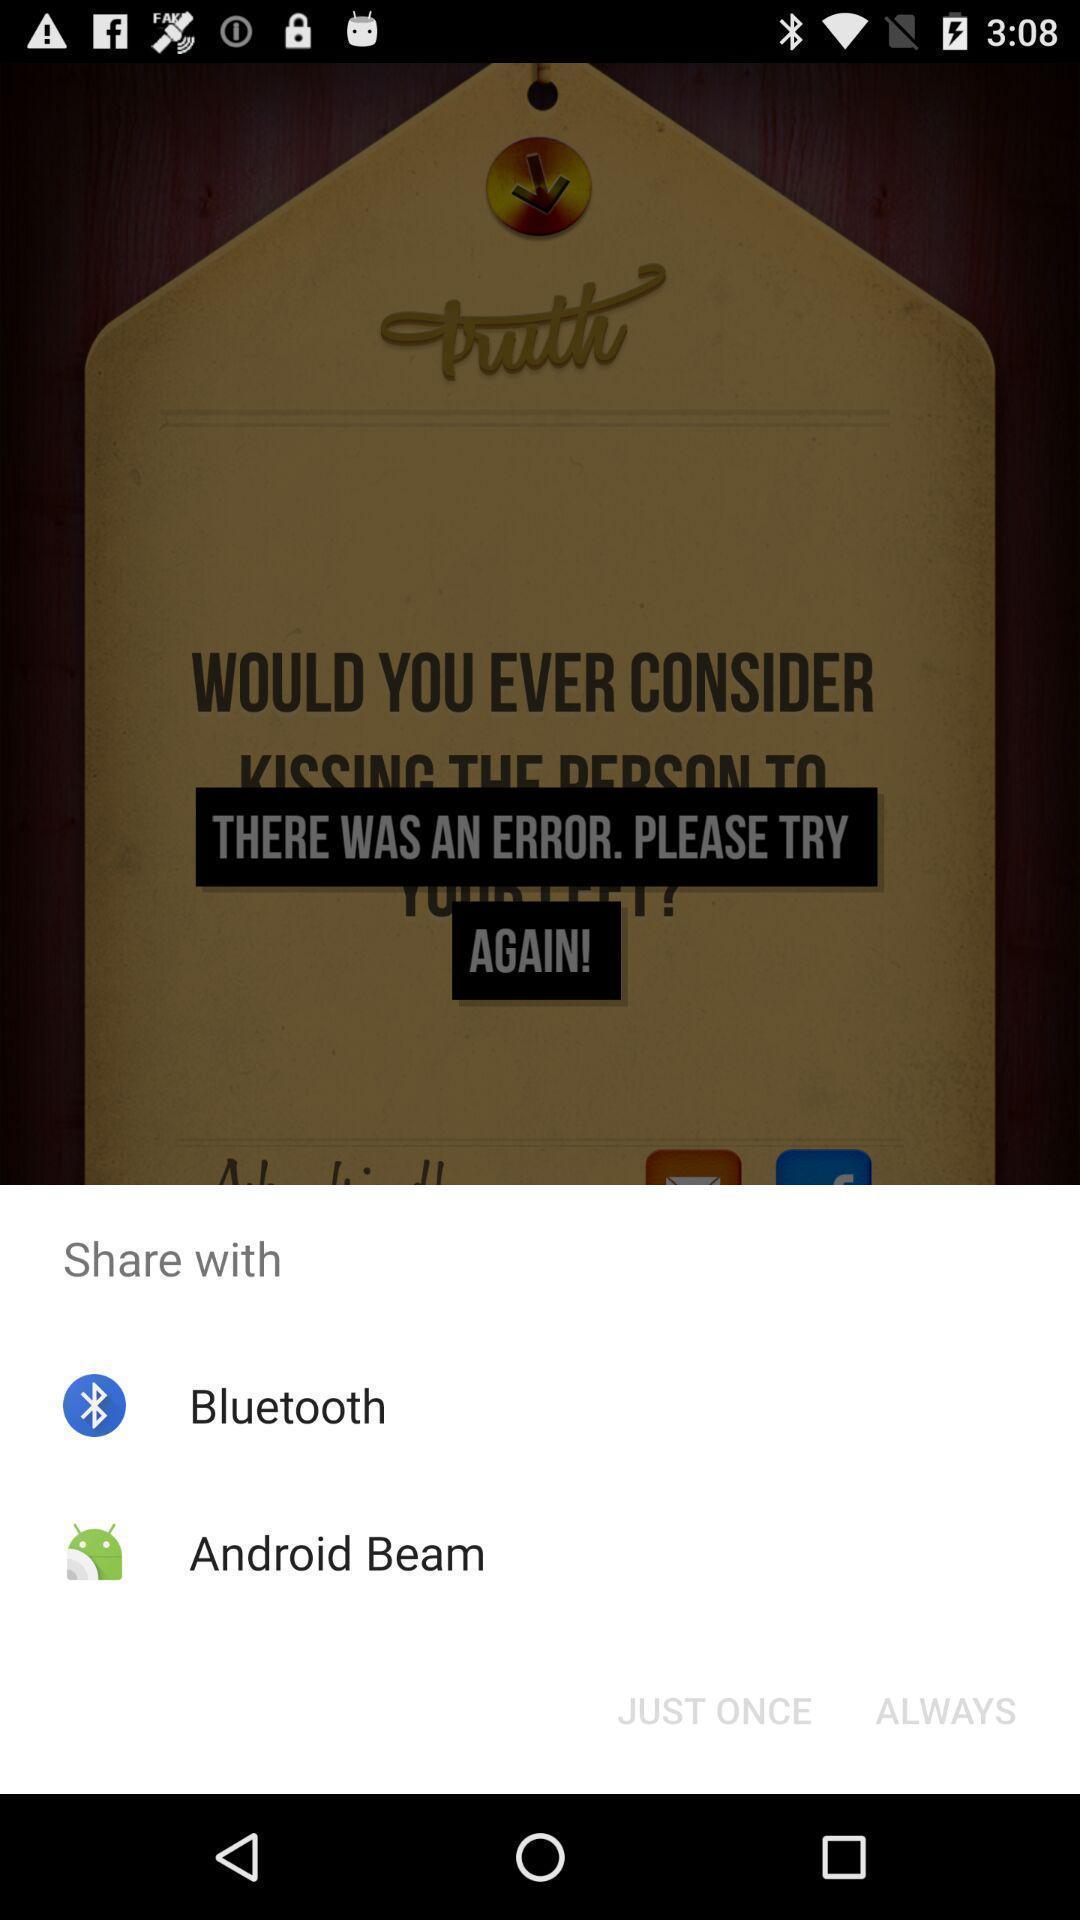Provide a textual representation of this image. Pop-up shows share option with multiple apps. 